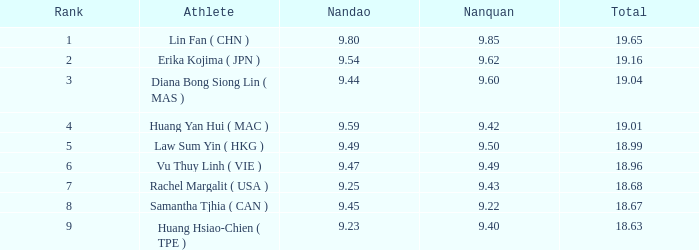Which Nanquan has a Nandao larger than 9.49, and a Rank of 4? 9.42. 